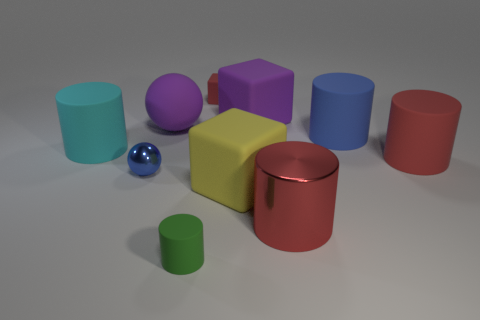How many other things are the same material as the green cylinder?
Make the answer very short. 7. What number of rubber things are gray cylinders or tiny blue things?
Make the answer very short. 0. There is a red thing on the left side of the yellow rubber object; is its shape the same as the green thing?
Provide a succinct answer. No. Is the number of big things that are in front of the yellow object greater than the number of purple metallic cylinders?
Ensure brevity in your answer.  Yes. What number of tiny things are both behind the tiny blue ball and on the left side of the tiny cylinder?
Offer a very short reply. 0. There is a big rubber cube behind the cube in front of the small sphere; what color is it?
Offer a terse response. Purple. How many tiny balls have the same color as the big shiny object?
Give a very brief answer. 0. There is a large rubber ball; is it the same color as the large matte cube that is behind the big cyan cylinder?
Give a very brief answer. Yes. Is the number of rubber spheres less than the number of purple matte objects?
Your answer should be very brief. Yes. Is the number of large rubber objects that are in front of the large purple ball greater than the number of small blue metal things that are on the right side of the small green thing?
Your response must be concise. Yes. 